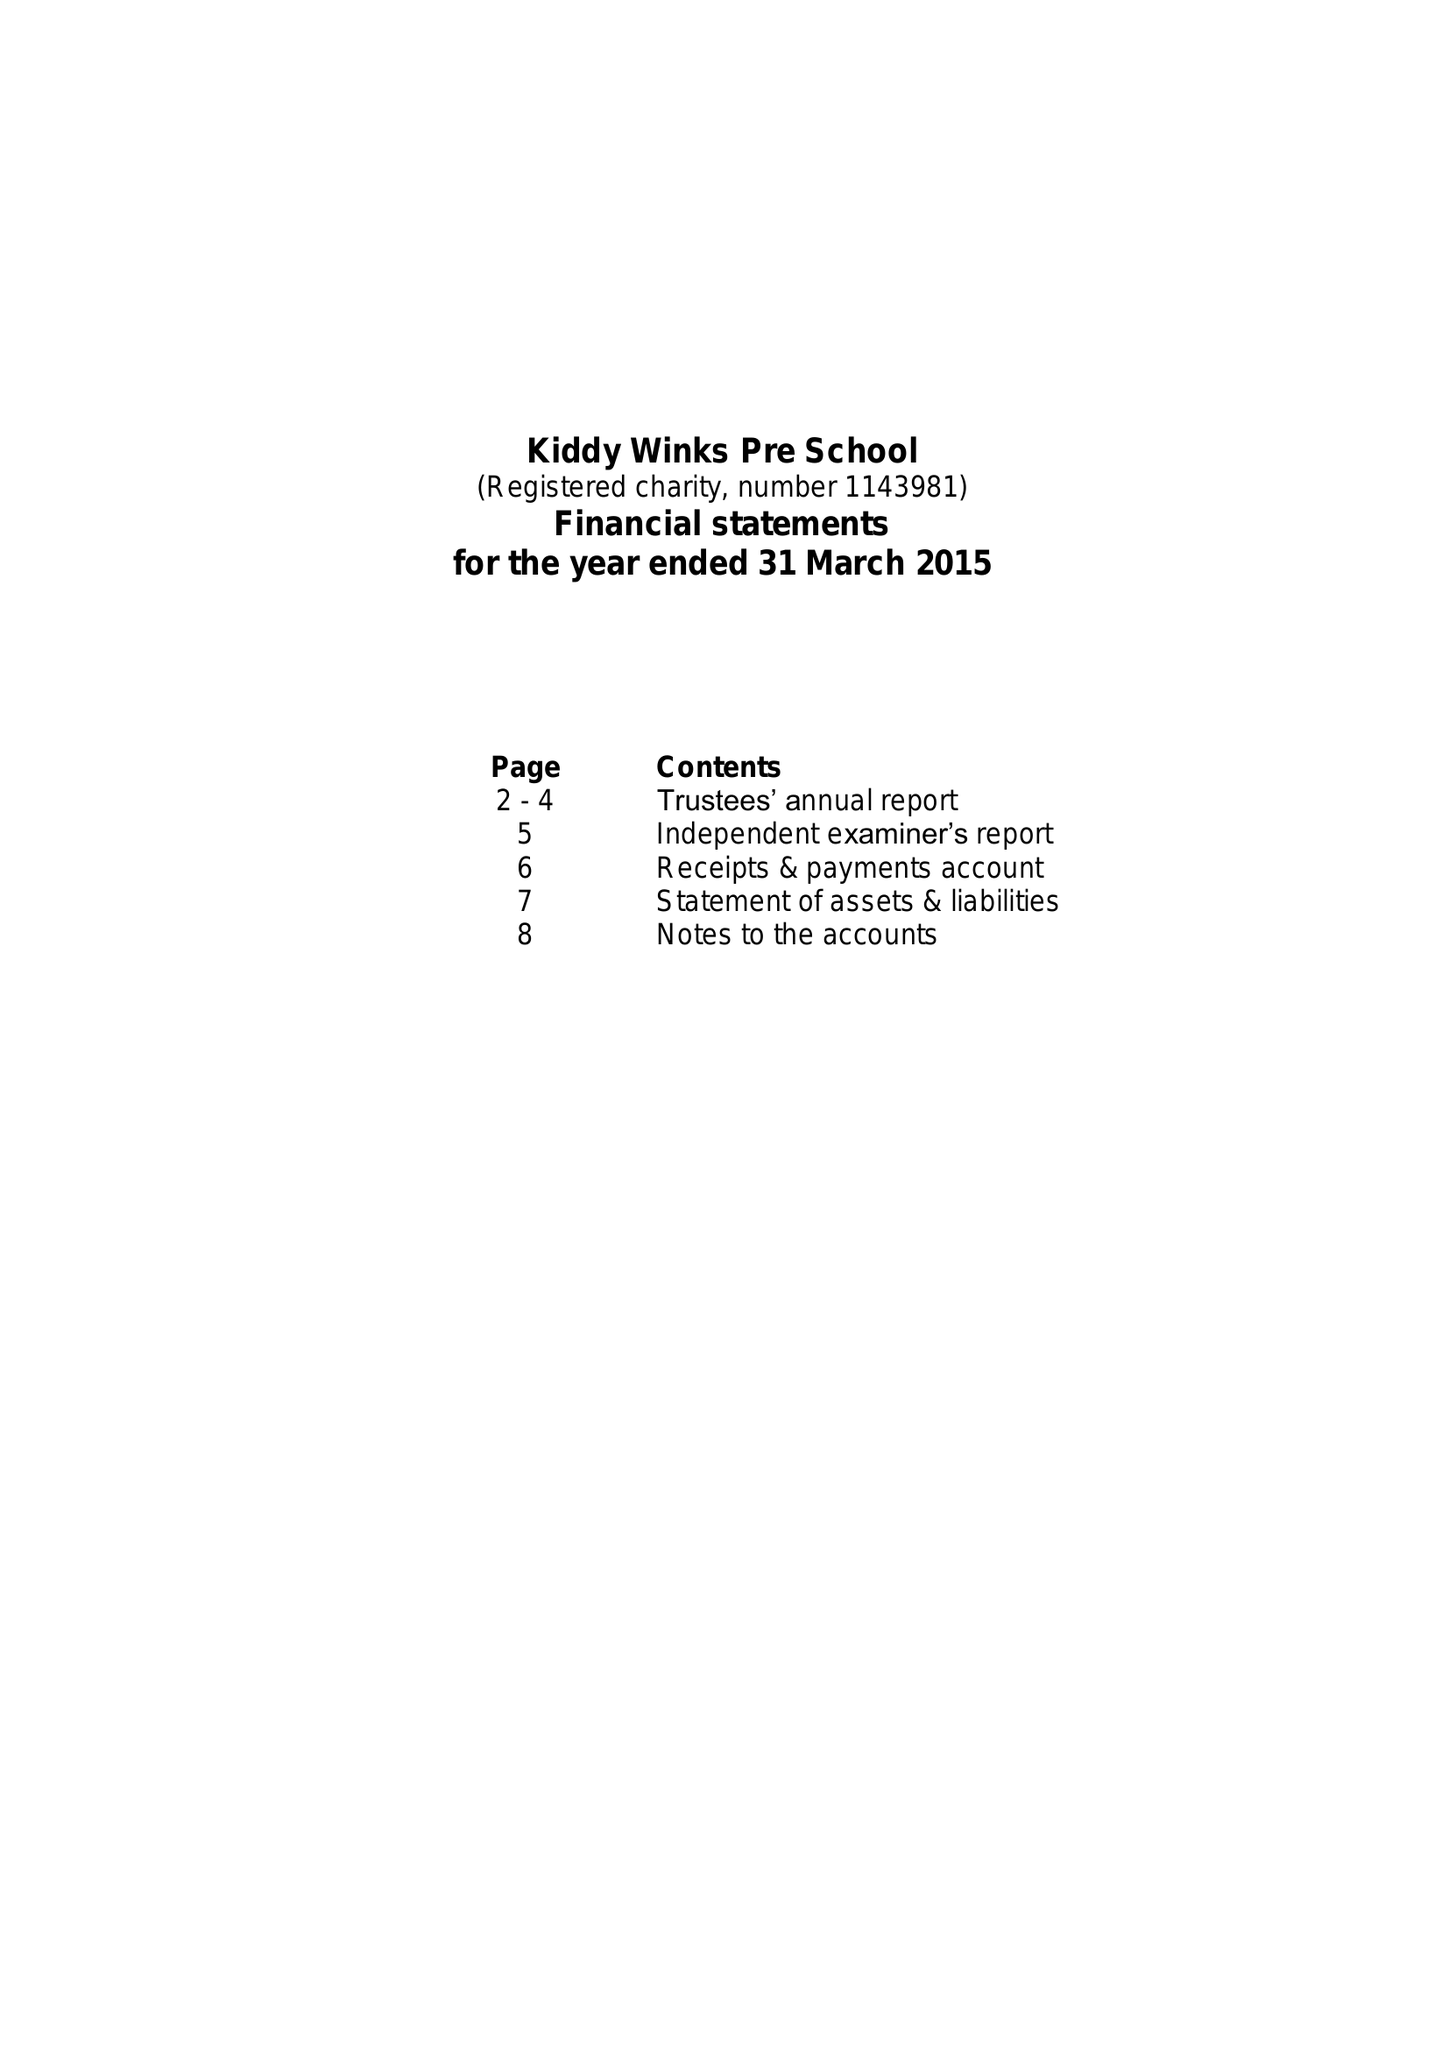What is the value for the report_date?
Answer the question using a single word or phrase. 2015-03-31 